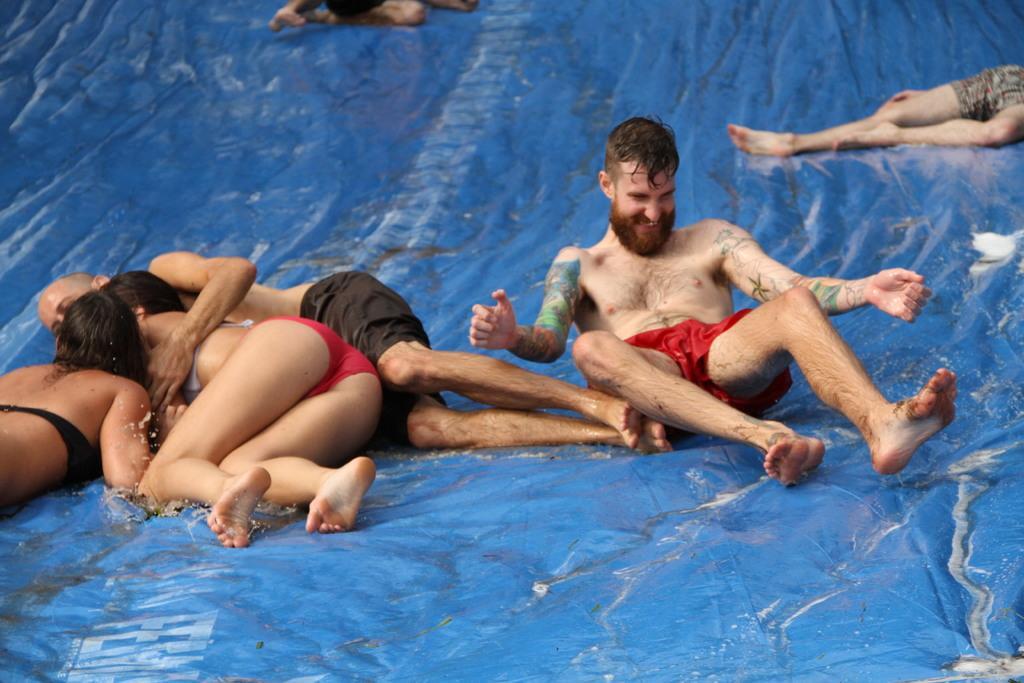Can you describe this image briefly? Some people are sliding down on a blue cover. 